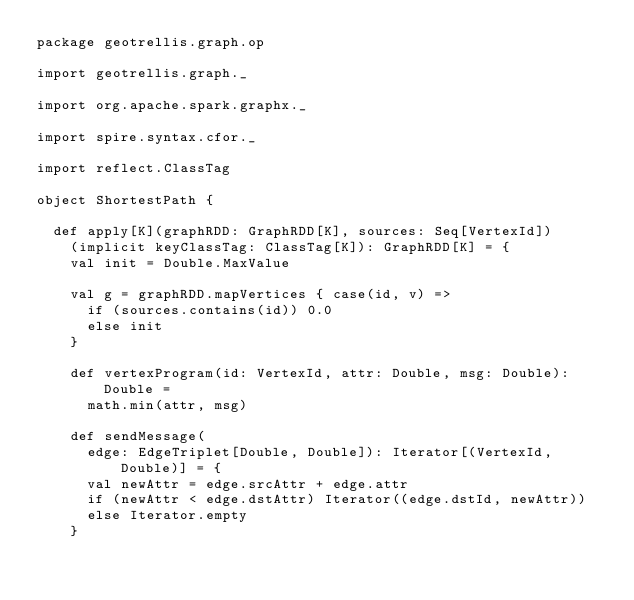Convert code to text. <code><loc_0><loc_0><loc_500><loc_500><_Scala_>package geotrellis.graph.op

import geotrellis.graph._

import org.apache.spark.graphx._

import spire.syntax.cfor._

import reflect.ClassTag

object ShortestPath {

  def apply[K](graphRDD: GraphRDD[K], sources: Seq[VertexId])
    (implicit keyClassTag: ClassTag[K]): GraphRDD[K] = {
    val init = Double.MaxValue

    val g = graphRDD.mapVertices { case(id, v) =>
      if (sources.contains(id)) 0.0
      else init
    }

    def vertexProgram(id: VertexId, attr: Double, msg: Double): Double =
      math.min(attr, msg)

    def sendMessage(
      edge: EdgeTriplet[Double, Double]): Iterator[(VertexId, Double)] = {
      val newAttr = edge.srcAttr + edge.attr
      if (newAttr < edge.dstAttr) Iterator((edge.dstId, newAttr))
      else Iterator.empty
    }
</code> 